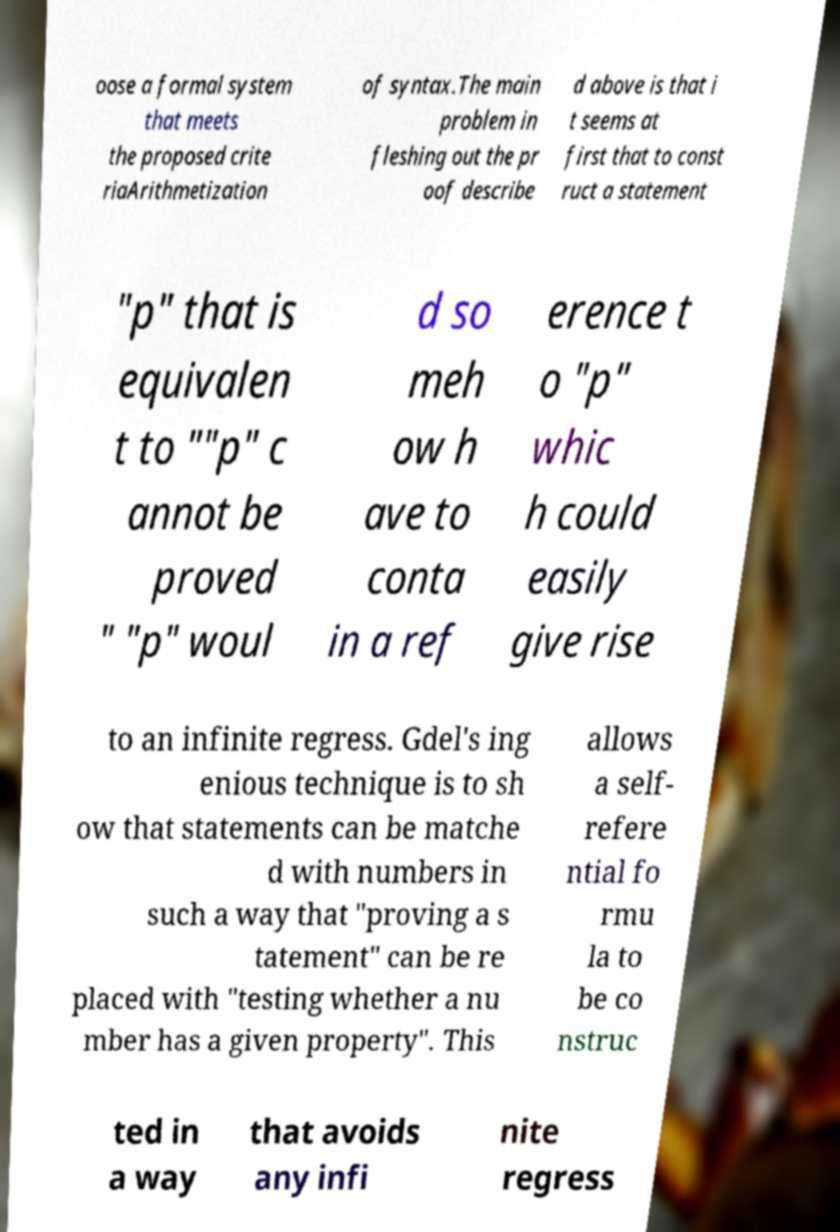For documentation purposes, I need the text within this image transcribed. Could you provide that? oose a formal system that meets the proposed crite riaArithmetization of syntax.The main problem in fleshing out the pr oof describe d above is that i t seems at first that to const ruct a statement "p" that is equivalen t to ""p" c annot be proved " "p" woul d so meh ow h ave to conta in a ref erence t o "p" whic h could easily give rise to an infinite regress. Gdel's ing enious technique is to sh ow that statements can be matche d with numbers in such a way that "proving a s tatement" can be re placed with "testing whether a nu mber has a given property". This allows a self- refere ntial fo rmu la to be co nstruc ted in a way that avoids any infi nite regress 